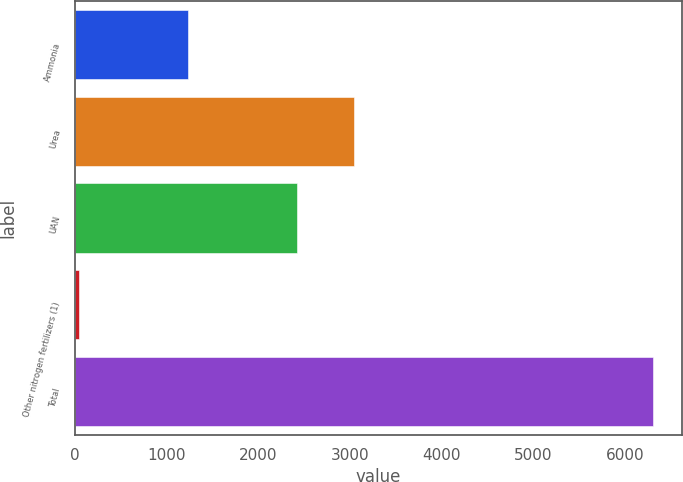Convert chart to OTSL. <chart><loc_0><loc_0><loc_500><loc_500><bar_chart><fcel>Ammonia<fcel>Urea<fcel>UAN<fcel>Other nitrogen fertilizers (1)<fcel>Total<nl><fcel>1226<fcel>3046.5<fcel>2420<fcel>45<fcel>6310<nl></chart> 